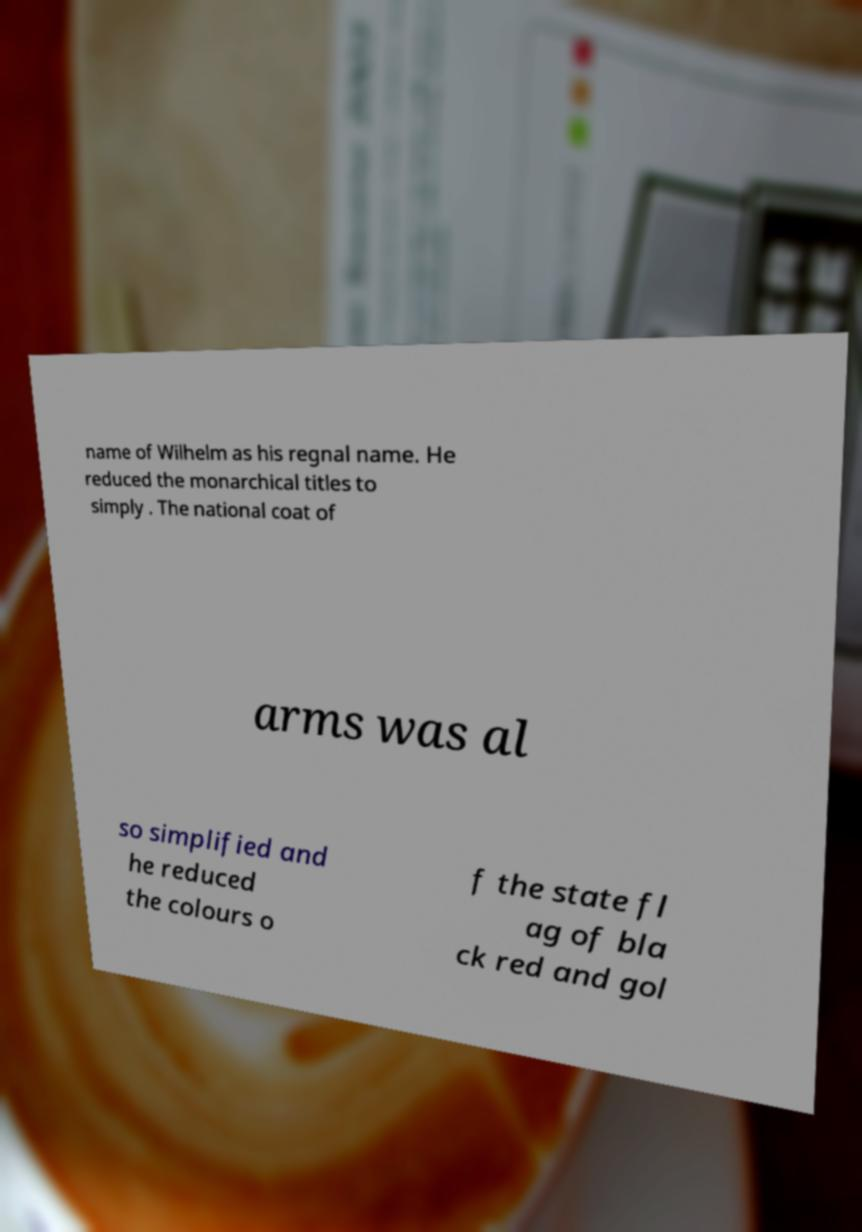Could you assist in decoding the text presented in this image and type it out clearly? name of Wilhelm as his regnal name. He reduced the monarchical titles to simply . The national coat of arms was al so simplified and he reduced the colours o f the state fl ag of bla ck red and gol 